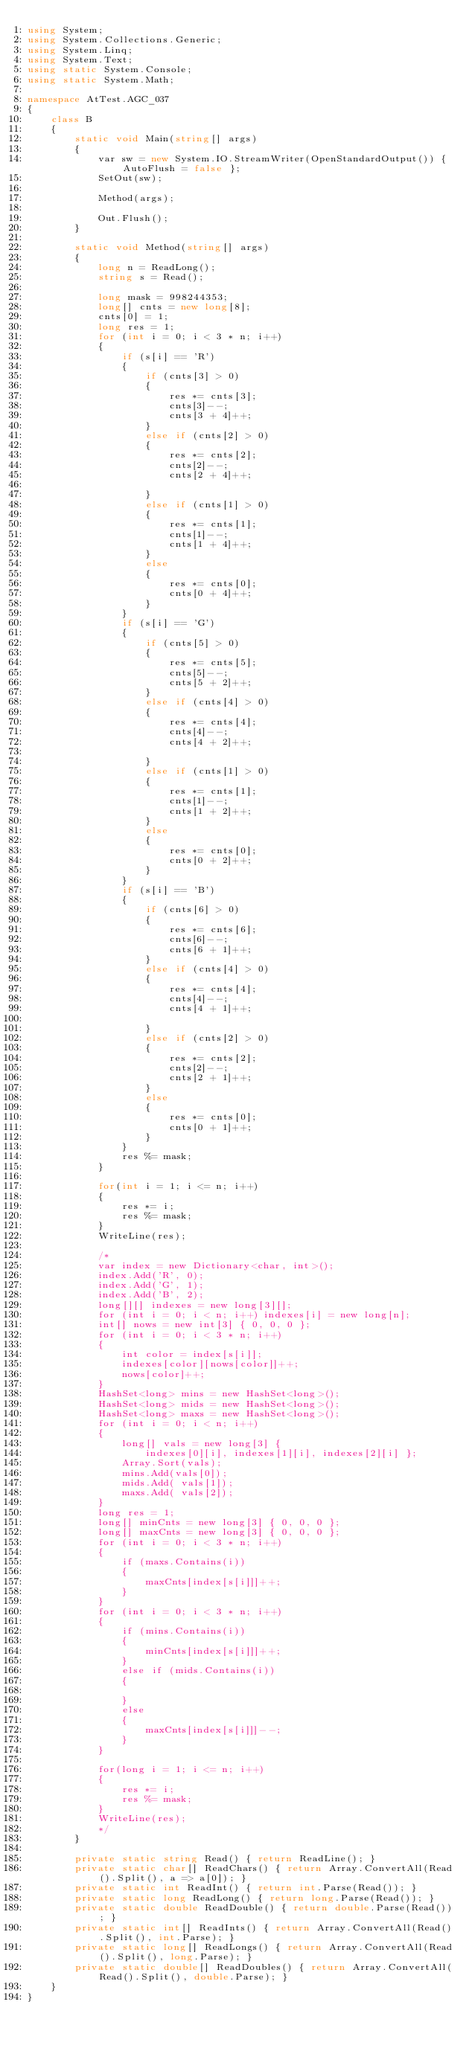<code> <loc_0><loc_0><loc_500><loc_500><_C#_>using System;
using System.Collections.Generic;
using System.Linq;
using System.Text;
using static System.Console;
using static System.Math;

namespace AtTest.AGC_037
{
    class B
    {
        static void Main(string[] args)
        {
            var sw = new System.IO.StreamWriter(OpenStandardOutput()) { AutoFlush = false };
            SetOut(sw);

            Method(args);

            Out.Flush();
        }

        static void Method(string[] args)
        {
            long n = ReadLong();
            string s = Read();

            long mask = 998244353;
            long[] cnts = new long[8];
            cnts[0] = 1;
            long res = 1;
            for (int i = 0; i < 3 * n; i++)
            {
                if (s[i] == 'R')
                {
                    if (cnts[3] > 0)
                    {
                        res *= cnts[3];
                        cnts[3]--;
                        cnts[3 + 4]++;
                    }
                    else if (cnts[2] > 0)
                    {
                        res *= cnts[2];
                        cnts[2]--;
                        cnts[2 + 4]++;

                    }
                    else if (cnts[1] > 0)
                    {
                        res *= cnts[1];
                        cnts[1]--;
                        cnts[1 + 4]++;
                    }
                    else
                    {
                        res *= cnts[0];
                        cnts[0 + 4]++;
                    }
                }
                if (s[i] == 'G')
                {
                    if (cnts[5] > 0)
                    {
                        res *= cnts[5];
                        cnts[5]--;
                        cnts[5 + 2]++;
                    }
                    else if (cnts[4] > 0)
                    {
                        res *= cnts[4];
                        cnts[4]--;
                        cnts[4 + 2]++;

                    }
                    else if (cnts[1] > 0)
                    {
                        res *= cnts[1];
                        cnts[1]--;
                        cnts[1 + 2]++;
                    }
                    else
                    {
                        res *= cnts[0];
                        cnts[0 + 2]++;
                    }
                }
                if (s[i] == 'B')
                {
                    if (cnts[6] > 0)
                    {
                        res *= cnts[6];
                        cnts[6]--;
                        cnts[6 + 1]++;
                    }
                    else if (cnts[4] > 0)
                    {
                        res *= cnts[4];
                        cnts[4]--;
                        cnts[4 + 1]++;

                    }
                    else if (cnts[2] > 0)
                    {
                        res *= cnts[2];
                        cnts[2]--;
                        cnts[2 + 1]++;
                    }
                    else
                    {
                        res *= cnts[0];
                        cnts[0 + 1]++;
                    }
                }
                res %= mask;
            }

            for(int i = 1; i <= n; i++)
            {
                res *= i;
                res %= mask;
            }
            WriteLine(res);

            /*
            var index = new Dictionary<char, int>();
            index.Add('R', 0);
            index.Add('G', 1);
            index.Add('B', 2);
            long[][] indexes = new long[3][];
            for (int i = 0; i < n; i++) indexes[i] = new long[n];
            int[] nows = new int[3] { 0, 0, 0 };
            for (int i = 0; i < 3 * n; i++)
            {
                int color = index[s[i]];
                indexes[color][nows[color]]++;
                nows[color]++;
            }
            HashSet<long> mins = new HashSet<long>();
            HashSet<long> mids = new HashSet<long>();
            HashSet<long> maxs = new HashSet<long>();
            for (int i = 0; i < n; i++)
            {
                long[] vals = new long[3] {
                    indexes[0][i], indexes[1][i], indexes[2][i] };
                Array.Sort(vals);
                mins.Add(vals[0]);
                mids.Add( vals[1]);
                maxs.Add( vals[2]);
            }
            long res = 1;
            long[] minCnts = new long[3] { 0, 0, 0 };
            long[] maxCnts = new long[3] { 0, 0, 0 };
            for (int i = 0; i < 3 * n; i++)
            {
                if (maxs.Contains(i))
                {
                    maxCnts[index[s[i]]]++;
                }
            }
            for (int i = 0; i < 3 * n; i++)
            {
                if (mins.Contains(i))
                {
                    minCnts[index[s[i]]]++;
                }
                else if (mids.Contains(i))
                {
                    
                }
                else
                {
                    maxCnts[index[s[i]]]--;
                }
            }

            for(long i = 1; i <= n; i++)
            {
                res *= i;
                res %= mask;
            }
            WriteLine(res);
            */
        }

        private static string Read() { return ReadLine(); }
        private static char[] ReadChars() { return Array.ConvertAll(Read().Split(), a => a[0]); }
        private static int ReadInt() { return int.Parse(Read()); }
        private static long ReadLong() { return long.Parse(Read()); }
        private static double ReadDouble() { return double.Parse(Read()); }
        private static int[] ReadInts() { return Array.ConvertAll(Read().Split(), int.Parse); }
        private static long[] ReadLongs() { return Array.ConvertAll(Read().Split(), long.Parse); }
        private static double[] ReadDoubles() { return Array.ConvertAll(Read().Split(), double.Parse); }
    }
}
</code> 